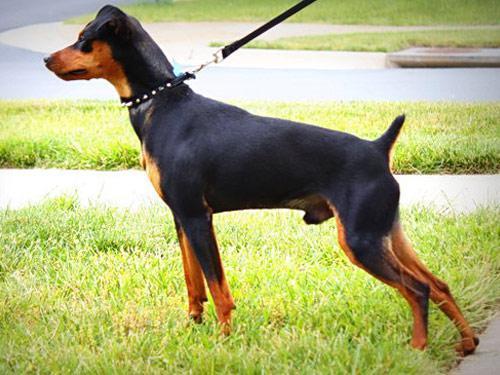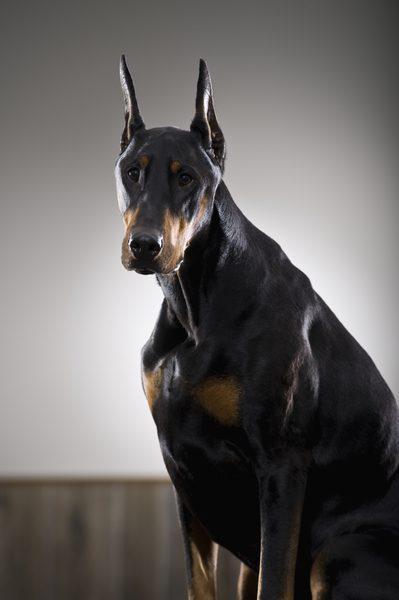The first image is the image on the left, the second image is the image on the right. Assess this claim about the two images: "An adult dog is with a puppy.". Correct or not? Answer yes or no. No. The first image is the image on the left, the second image is the image on the right. Evaluate the accuracy of this statement regarding the images: "The dog in the image on the left is situated in the grass.". Is it true? Answer yes or no. Yes. 